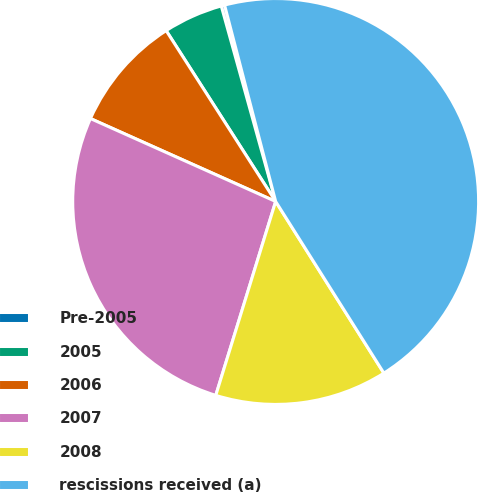Convert chart. <chart><loc_0><loc_0><loc_500><loc_500><pie_chart><fcel>Pre-2005<fcel>2005<fcel>2006<fcel>2007<fcel>2008<fcel>rescissions received (a)<nl><fcel>0.27%<fcel>4.75%<fcel>9.23%<fcel>26.93%<fcel>13.72%<fcel>45.1%<nl></chart> 